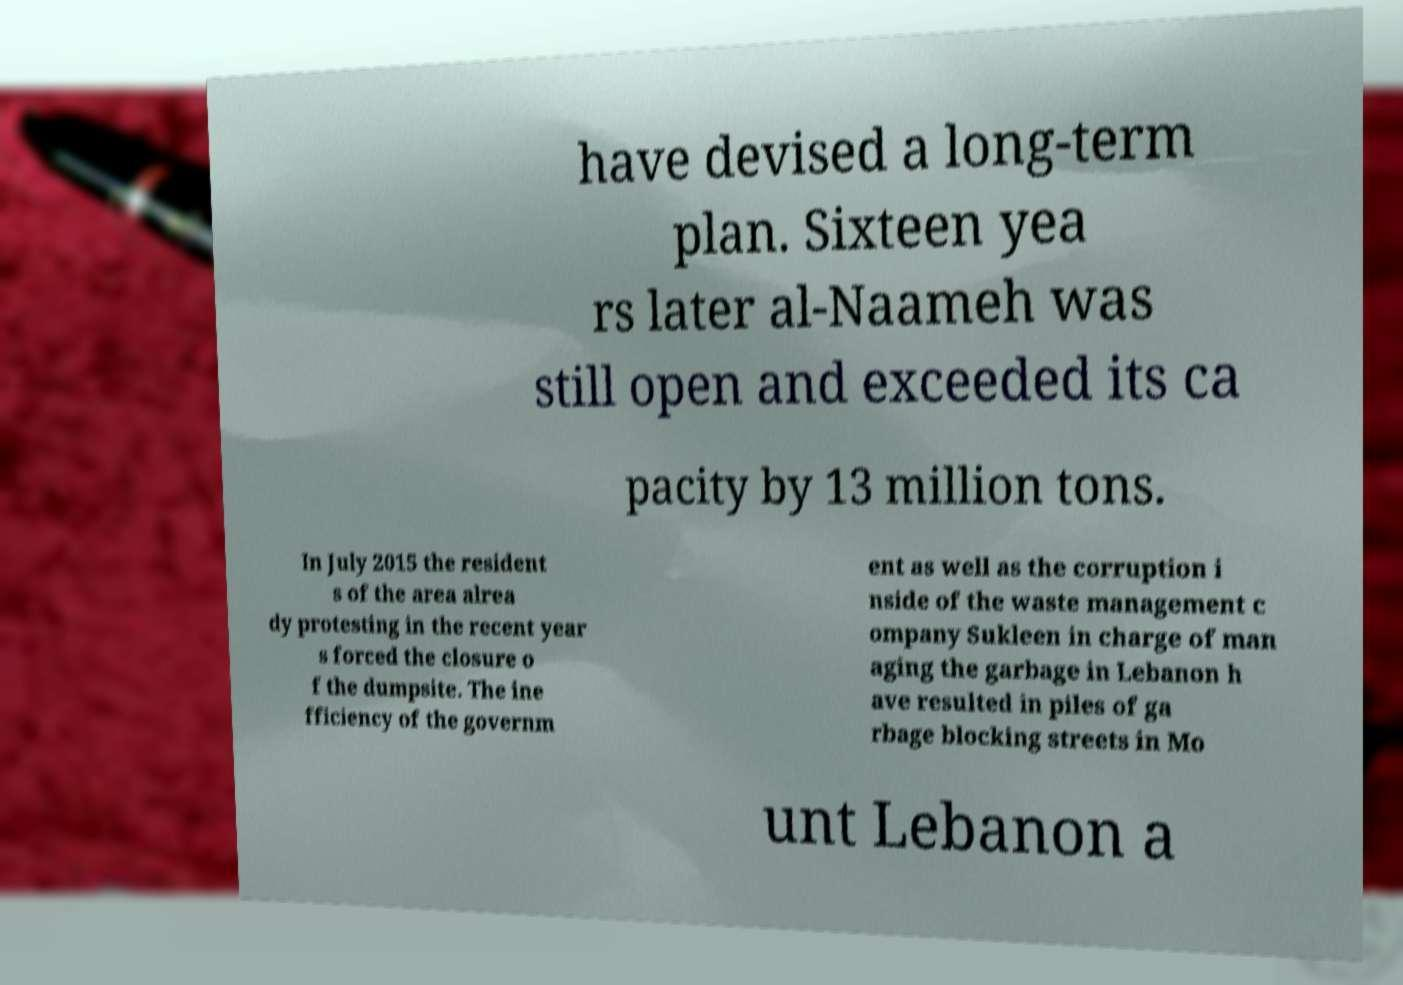Could you extract and type out the text from this image? have devised a long-term plan. Sixteen yea rs later al-Naameh was still open and exceeded its ca pacity by 13 million tons. In July 2015 the resident s of the area alrea dy protesting in the recent year s forced the closure o f the dumpsite. The ine fficiency of the governm ent as well as the corruption i nside of the waste management c ompany Sukleen in charge of man aging the garbage in Lebanon h ave resulted in piles of ga rbage blocking streets in Mo unt Lebanon a 